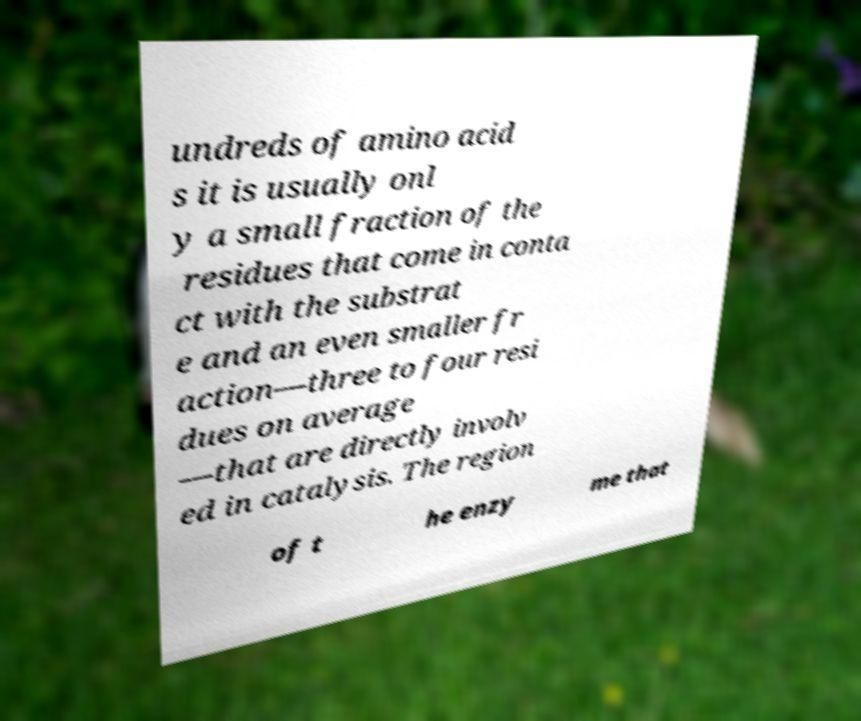Please identify and transcribe the text found in this image. undreds of amino acid s it is usually onl y a small fraction of the residues that come in conta ct with the substrat e and an even smaller fr action—three to four resi dues on average —that are directly involv ed in catalysis. The region of t he enzy me that 